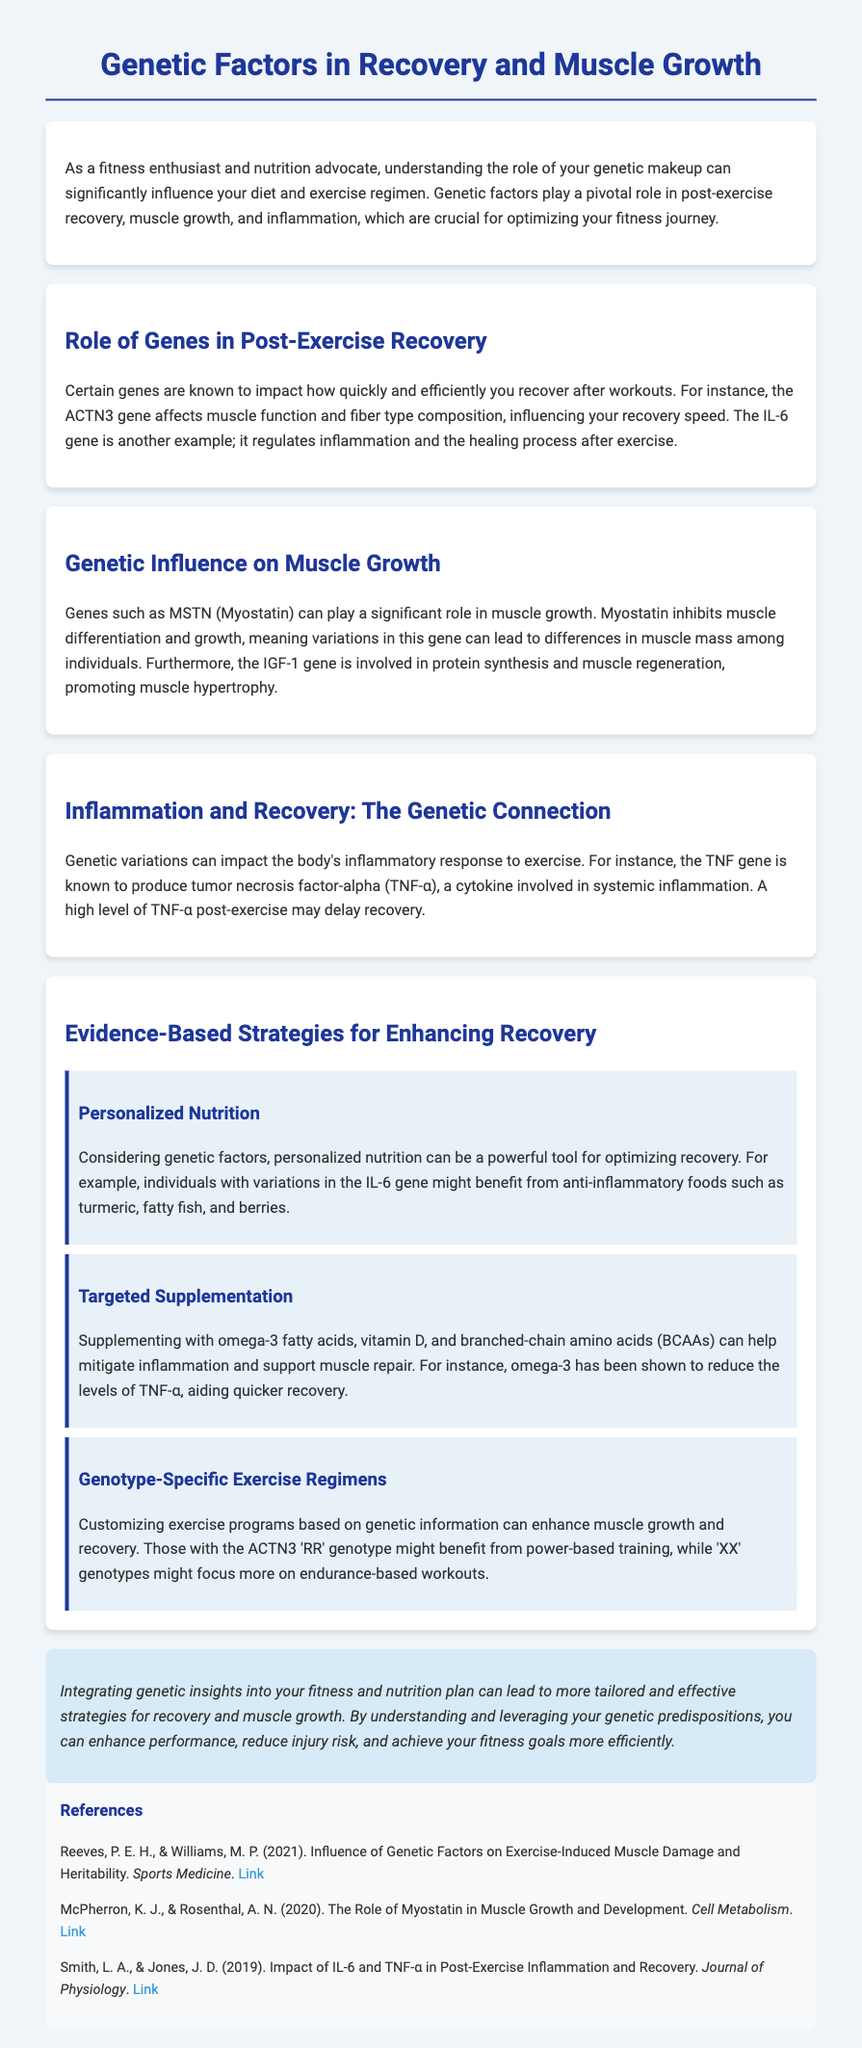What is the ACTN3 gene related to? The ACTN3 gene affects muscle function and fiber type composition, influencing recovery speed.
Answer: Muscle function Which gene regulates inflammation? The gene known for regulating inflammation, particularly in post-exercise recovery, is IL-6.
Answer: IL-6 What role does the MSTN gene play? The MSTN (Myostatin) gene inhibits muscle differentiation and growth, affecting muscle mass.
Answer: Inhibits muscle growth Which cytokine is involved in systemic inflammation? The cytokine involved in systemic inflammation mentioned is tumor necrosis factor-alpha (TNF-α).
Answer: TNF-α What nutrient is suggested for individuals with variations in IL-6? Anti-inflammatory foods such as turmeric, fatty fish, and berries are suggested for those with variations in IL-6.
Answer: Anti-inflammatory foods How can omega-3 fatty acids help recovery? Omega-3 fatty acids can help mitigate inflammation and support muscle repair by reducing TNF-α levels.
Answer: Reduce TNF-α levels What exercise regimen is suggested for the ACTN3 'RR' genotype? Individuals with the ACTN3 'RR' genotype might benefit from power-based training.
Answer: Power-based training What is the concluding statement about integrating genetic insights? Integrating genetic insights can lead to more tailored and effective strategies for recovery and muscle growth.
Answer: Tailored strategies Which publication discusses the influence of genetic factors on exercise-induced muscle damage? The publication discussing this topic is by Reeves and Williams (2021).
Answer: Reeves and Williams (2021) 